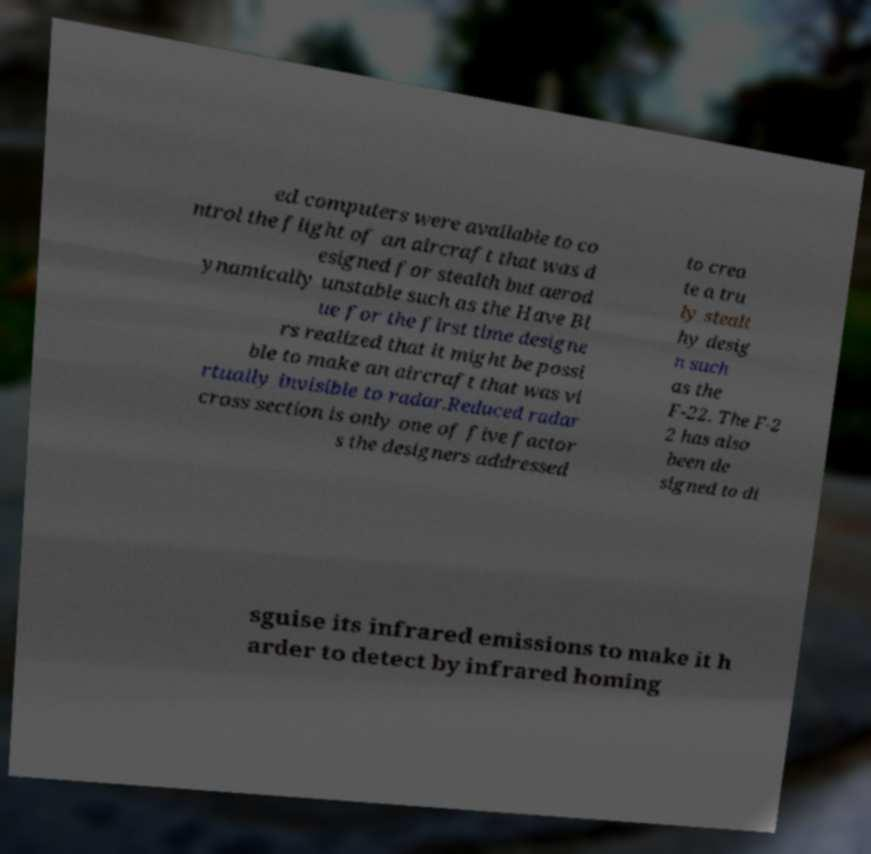Can you read and provide the text displayed in the image?This photo seems to have some interesting text. Can you extract and type it out for me? ed computers were available to co ntrol the flight of an aircraft that was d esigned for stealth but aerod ynamically unstable such as the Have Bl ue for the first time designe rs realized that it might be possi ble to make an aircraft that was vi rtually invisible to radar.Reduced radar cross section is only one of five factor s the designers addressed to crea te a tru ly stealt hy desig n such as the F-22. The F-2 2 has also been de signed to di sguise its infrared emissions to make it h arder to detect by infrared homing 